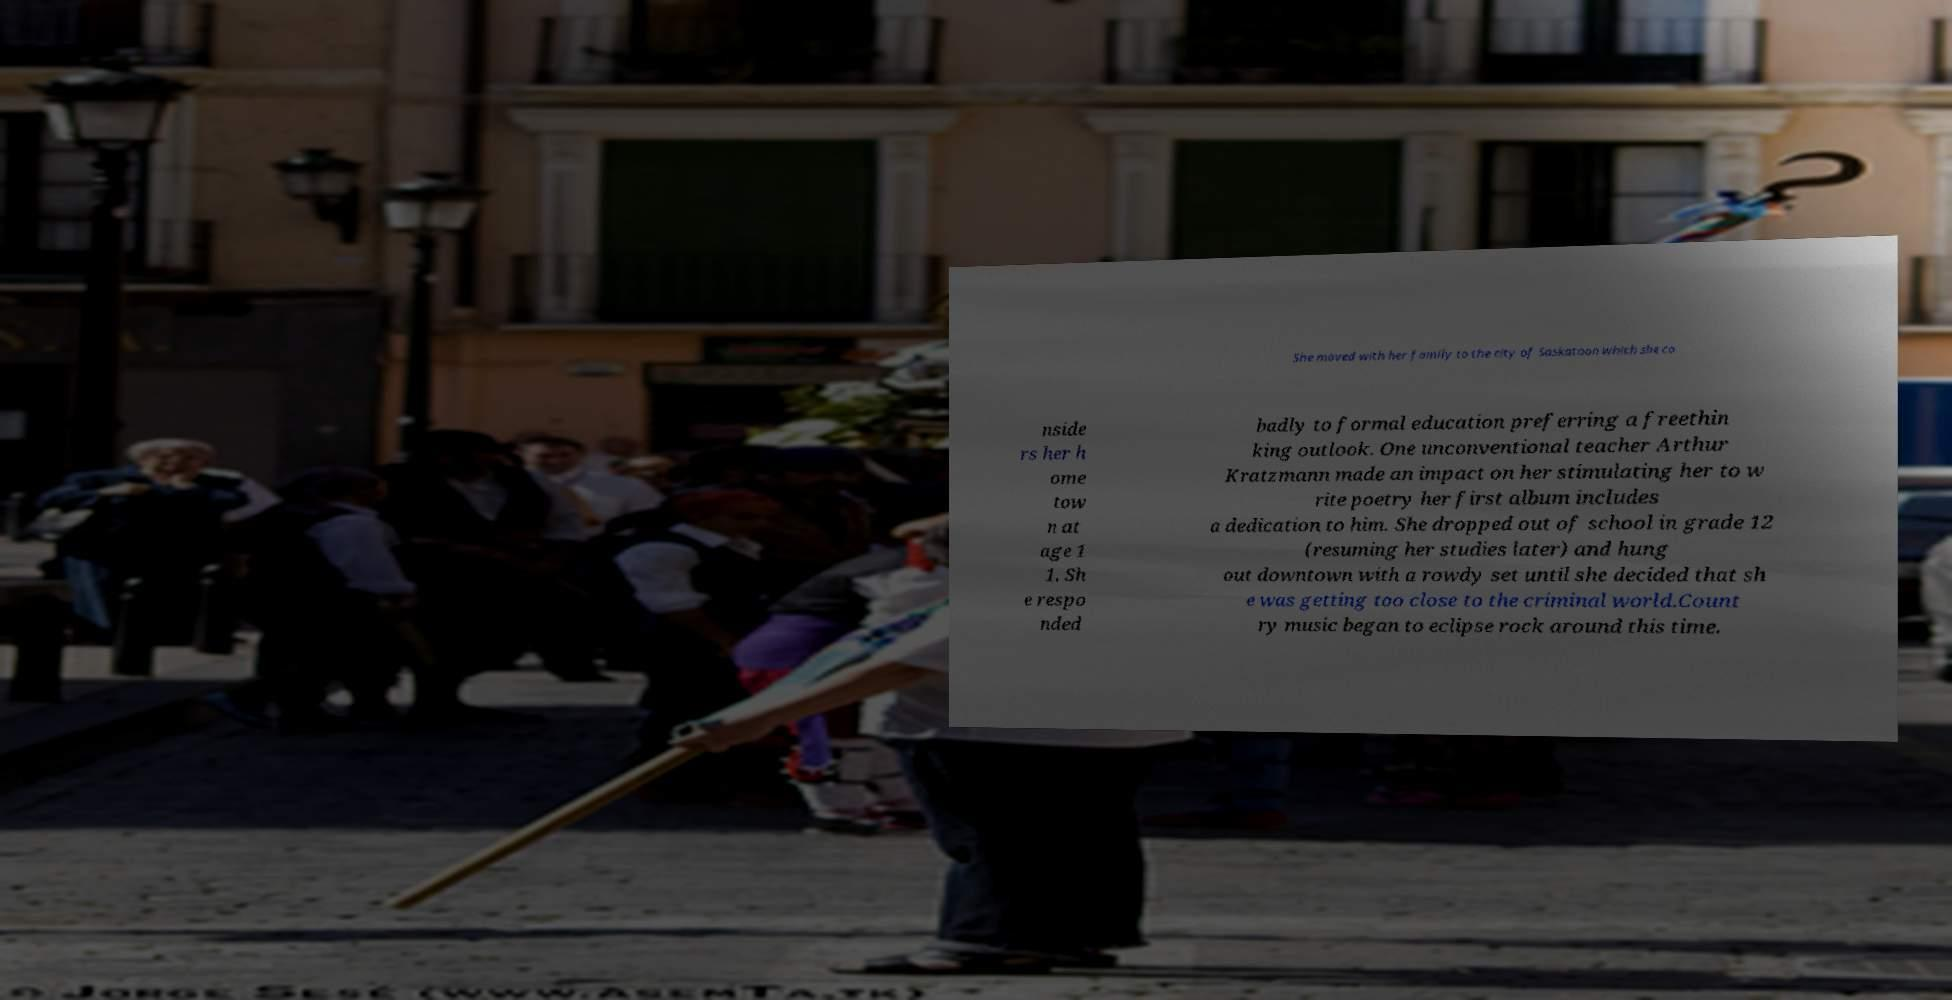Can you read and provide the text displayed in the image?This photo seems to have some interesting text. Can you extract and type it out for me? She moved with her family to the city of Saskatoon which she co nside rs her h ome tow n at age 1 1. Sh e respo nded badly to formal education preferring a freethin king outlook. One unconventional teacher Arthur Kratzmann made an impact on her stimulating her to w rite poetry her first album includes a dedication to him. She dropped out of school in grade 12 (resuming her studies later) and hung out downtown with a rowdy set until she decided that sh e was getting too close to the criminal world.Count ry music began to eclipse rock around this time. 